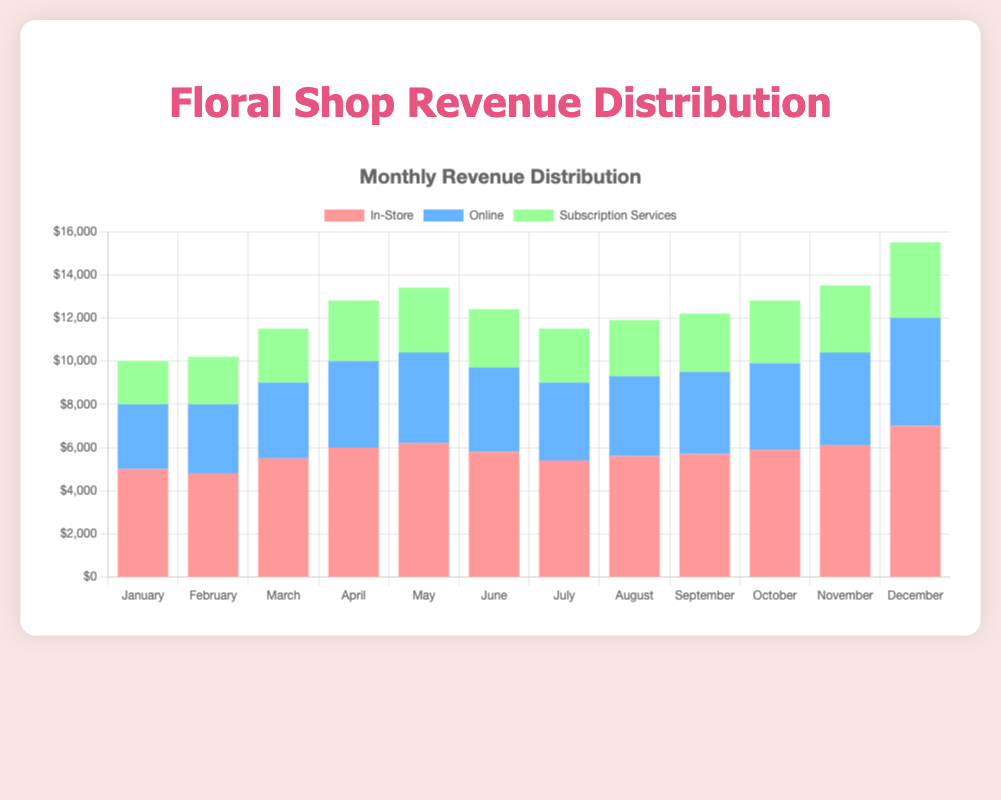Which month had the highest total revenue? Adding the revenues from In-Store, Online, and Subscription Services for each month shows that December has the highest total revenue of $15,500 ($7,000 + $5,000 + $3,500).
Answer: December Which sales channel had the most consistent revenue throughout the year? Comparing the monthly revenues for each sales channel, the most consistent appears to be Subscription Services, having moderately stable revenues ranging from $2,000 to $3,500.
Answer: Subscription Services In which month did the Online sales channel see its highest revenue? Looking at the online revenue data, the highest values are seen in December at $5,000.
Answer: December What is the total revenue for In-Store sales in the first quarter (January to March)? The total revenue for In-Store in Q1 is calculated as $5,000 (January) + $4,800 (February) + $5,500 (March) = $15,300.
Answer: $15,300 How much more revenue did In-Store sales generate compared to Subscription Services in November? In November, In-Store sales generated $6,100 and Subscription Services generated $3,100. The difference is $6,100 - $3,100 = $3,000.
Answer: $3,000 Which sales channel showed the most growth in revenue from January to December? Comparing the revenues for January and December: In-Store ($5,000 to $7,000), Online ($3,000 to $5,000), Subscription Services ($2,000 to $3,500). The largest absolute growth is for Online, with an increase of $2,000.
Answer: Online Did any month have the same revenue from two different sales channels? By examining each month, there are no instances wherein two different sales channels have the exact same revenue in any month.
Answer: No What is the average monthly revenue for Online sales? The total online revenue for all months is $44,300, and there are 12 months, so the average is $44,300 / 12 ≈ $3,692 per month.
Answer: $3,692 Between March and April, which sales channel had the largest increase in revenue, and by how much? In-Store increased by $500, Online increased by $500, and Subscription Services increased by $300. Both In-Store and Online had the largest increase of $500.
Answer: In-Store and Online, $500 Which month had the lowest combined revenue from all sales channels? Summing the revenues for each month, February has the lowest combined revenue with $4,800 + $3,200 + $2,200 = $10,200.
Answer: February 